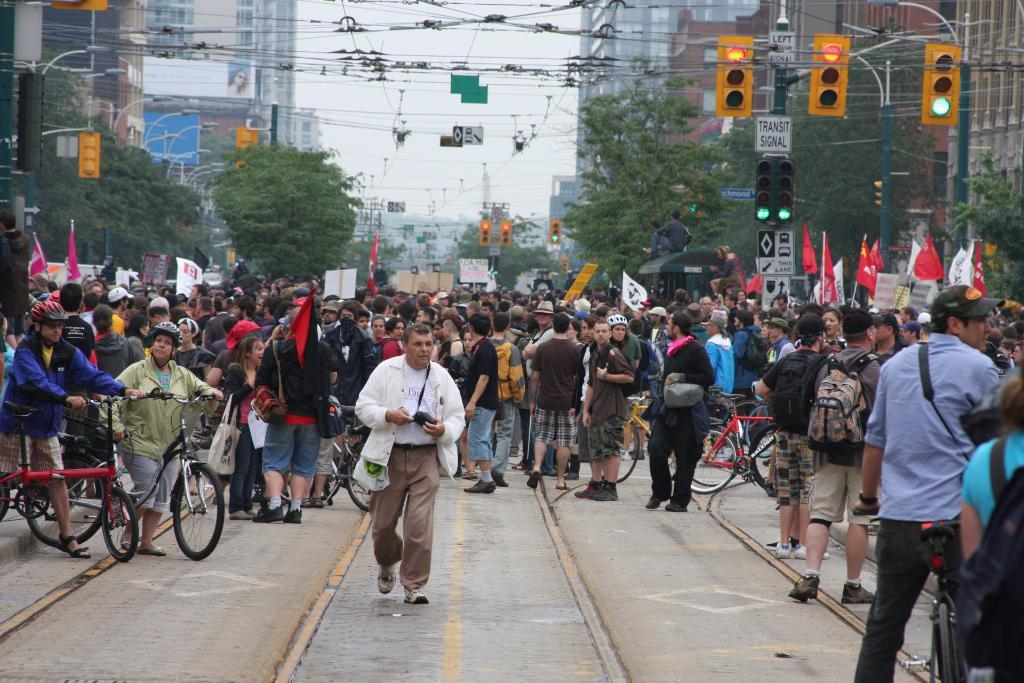What are the people in the image doing? There are people standing in the image, and one person is walking. What can be seen in the image besides people? There are bicycles, buildings, trees, and traffic lights in the image. What type of line can be seen on the side of the road in the image? There is no line visible on the side of the road in the image. What is the chalk used for in the image? There is no chalk present in the image. 